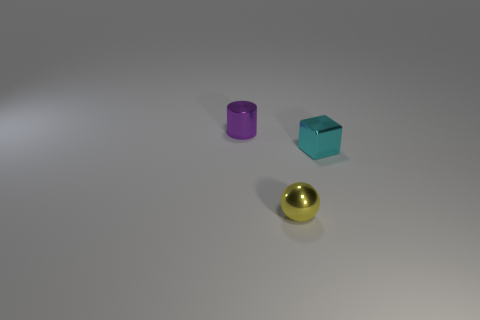There is a cyan object that is the same size as the purple cylinder; what shape is it?
Offer a terse response. Cube. Is the small yellow object the same shape as the cyan metal thing?
Provide a short and direct response. No. What number of other metallic things are the same shape as the yellow metallic thing?
Keep it short and to the point. 0. There is a small metal cylinder; how many tiny shiny cylinders are left of it?
Provide a succinct answer. 0. There is a shiny object behind the cyan metal cube; is it the same color as the small shiny sphere?
Your answer should be very brief. No. What number of cylinders are the same size as the cyan object?
Your answer should be very brief. 1. There is a small cyan thing that is the same material as the purple cylinder; what shape is it?
Your answer should be compact. Cube. Is there a metal object that has the same color as the metal cube?
Make the answer very short. No. What is the cube made of?
Offer a terse response. Metal. How many objects are either cubes or yellow metal objects?
Offer a very short reply. 2. 